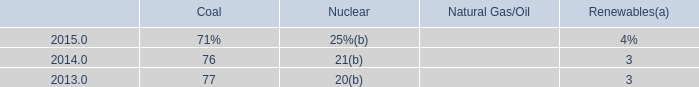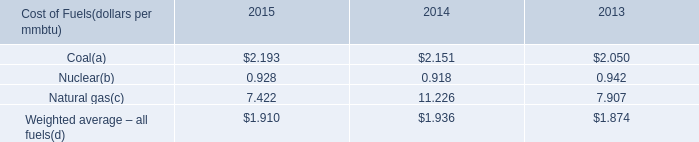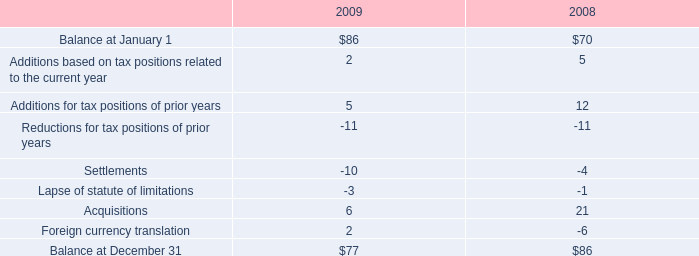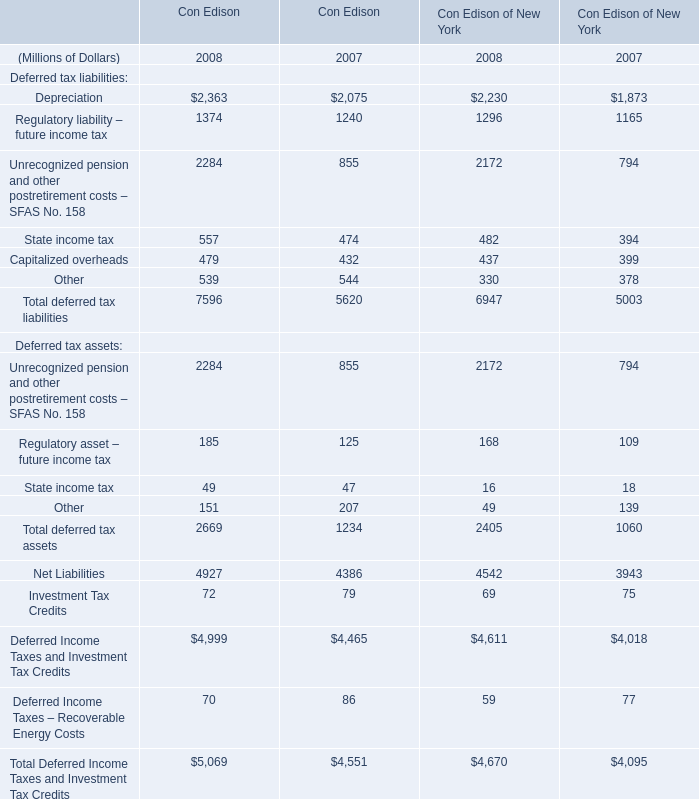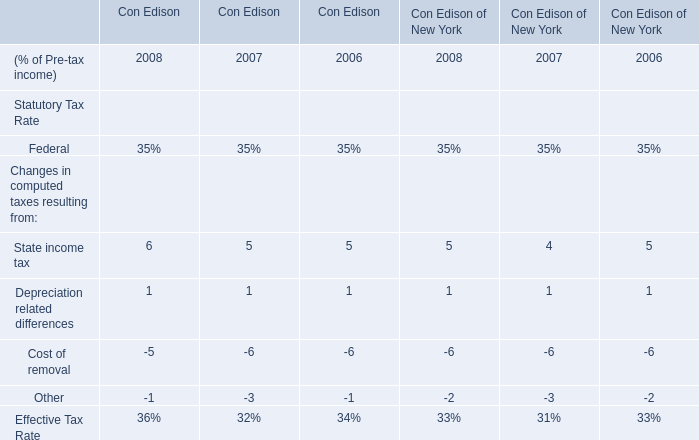In the year with lowest amount of Depreciation, what's the increasing rate of Regulatory liability – future income tax? 
Computations: (((1374 + 1296) - (1240 + 1165)) / (1240 + 1165))
Answer: 0.11019. 